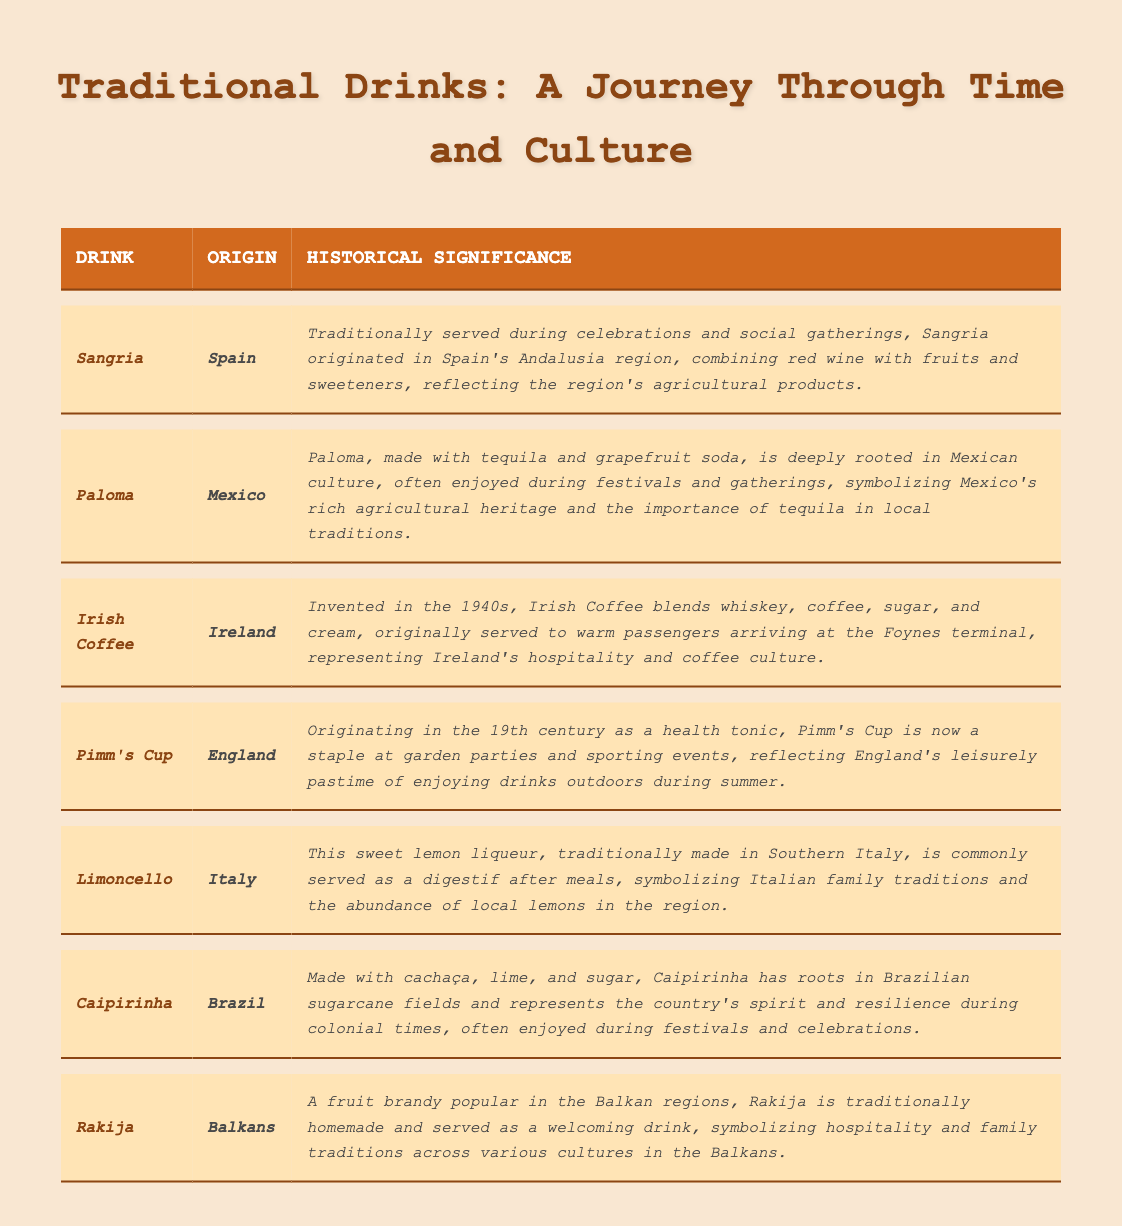What is the origin of Sangria? The table lists Sangria under the "Origin" column where it shows Spain as its origin.
Answer: Spain Which drink is known for its historical significance related to festivals in Mexican culture? By reviewing the historical significance entries in the table, Paloma is described as being deeply rooted in Mexican culture and enjoyed during festivals.
Answer: Paloma True or False: Irish Coffee was invented in the 1940s. The historical significance section for Irish Coffee explicitly states that it was invented in the 1940s.
Answer: True What is the common serving occasion for Pimm's Cup according to the table? The historical significance of Pimm's Cup mentions it as a staple at garden parties and sporting events, indicating these are common occasions for serving it.
Answer: Garden parties and sporting events Which drink represents Italian family traditions? The entry for Limoncello indicates that it symbolizes Italian family traditions, as noted in its historical significance.
Answer: Limoncello How many drinks listed in the table originate from Europe? The table includes Sangria from Spain, Irish Coffee from Ireland, Pimm's Cup from England, and Limoncello from Italy, totaling four drinks from Europe.
Answer: 4 What drink features cachaça as an ingredient, and what does it signify? According to the table, Caipirinha features cachaça and represents Brazil’s spirit and resilience, which is mentioned in its historical significance.
Answer: Caipirinha Is Rakija a fruit brandy, and where is it popular? The table’s entry for Rakija confirms it is a fruit brandy and indicates its popularity in the Balkan regions.
Answer: Yes, in the Balkans Which drink has the most recent invention date, and when was it invented? The table shows that Irish Coffee was invented in the 1940s, which is the most recent date among the drinks listed.
Answer: Irish Coffee, 1940s What do Sangria and Paloma have in common, based on their historical significance? Both drinks are highlighted for being traditionally served during celebrations and social gatherings, as noted in their respective historical significance entries.
Answer: They are served during celebrations and social gatherings 